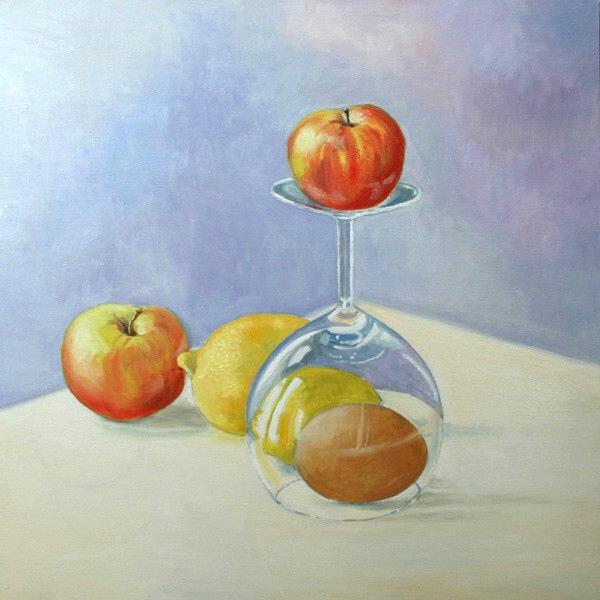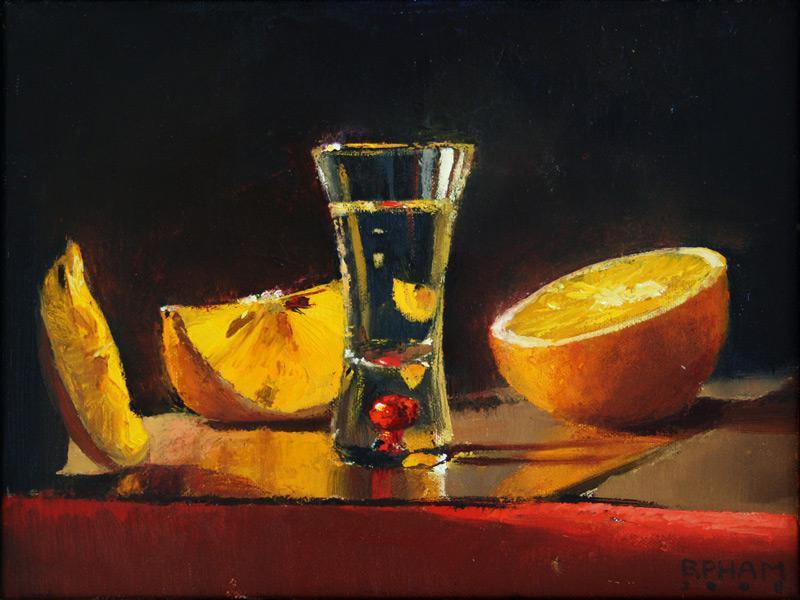The first image is the image on the left, the second image is the image on the right. Given the left and right images, does the statement "At least three whole lemons are sitting near a container of water in the image on the right." hold true? Answer yes or no. No. The first image is the image on the left, the second image is the image on the right. Examine the images to the left and right. Is the description "The left image depicts a stemmed glass next to a whole lemon, and the right image includes a glass of clear liquid and a sliced fruit." accurate? Answer yes or no. Yes. 